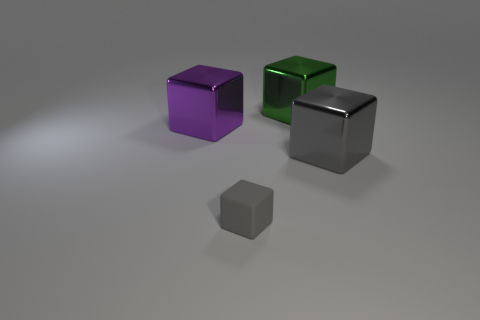Subtract all green metallic blocks. How many blocks are left? 3 Add 3 blocks. How many objects exist? 7 Subtract all cyan blocks. Subtract all gray spheres. How many blocks are left? 4 Subtract 0 cyan cubes. How many objects are left? 4 Subtract all small rubber things. Subtract all large gray cylinders. How many objects are left? 3 Add 4 metallic cubes. How many metallic cubes are left? 7 Add 2 purple metal blocks. How many purple metal blocks exist? 3 